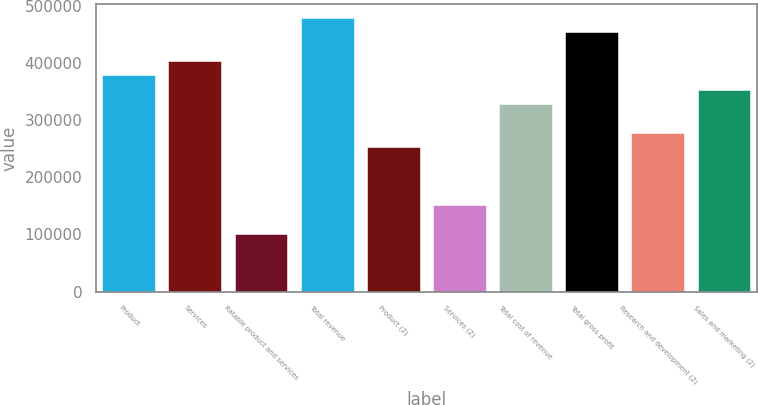Convert chart to OTSL. <chart><loc_0><loc_0><loc_500><loc_500><bar_chart><fcel>Product<fcel>Services<fcel>Ratable product and services<fcel>Total revenue<fcel>Product (2)<fcel>Services (2)<fcel>Total cost of revenue<fcel>Total gross profit<fcel>Research and development (2)<fcel>Sales and marketing (2)<nl><fcel>378172<fcel>403384<fcel>100846<fcel>479018<fcel>252115<fcel>151269<fcel>327749<fcel>453806<fcel>277326<fcel>352961<nl></chart> 